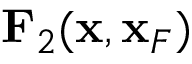<formula> <loc_0><loc_0><loc_500><loc_500>{ F } _ { 2 } ( { x } , { x } _ { F } )</formula> 